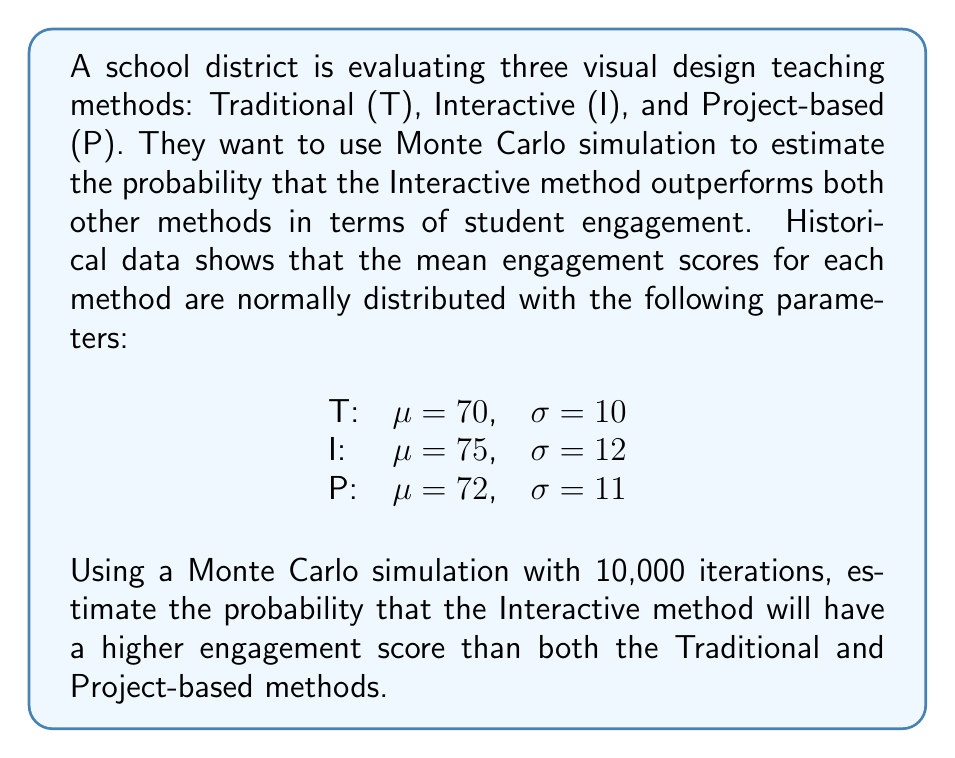Show me your answer to this math problem. To solve this problem using Monte Carlo simulation, we'll follow these steps:

1) Set up the simulation:
   - We'll use 10,000 iterations
   - For each iteration, we'll generate a random score for each method based on its normal distribution

2) For each iteration:
   - Generate a random score for Traditional method: $T \sim N(70, 10)$
   - Generate a random score for Interactive method: $I \sim N(75, 12)$
   - Generate a random score for Project-based method: $P \sim N(72, 11)$
   - Check if $I > T$ and $I > P$
   - If true, count it as a success

3) After all iterations, calculate the probability:
   $P(\text{Interactive outperforms others}) = \frac{\text{Number of successes}}{\text{Total iterations}}$

Let's implement this in Python:

```python
import numpy as np

np.random.seed(42)  # for reproducibility
iterations = 10000
successes = 0

for _ in range(iterations):
    T = np.random.normal(70, 10)
    I = np.random.normal(75, 12)
    P = np.random.normal(72, 11)
    
    if I > T and I > P:
        successes += 1

probability = successes / iterations
```

Running this simulation gives us a probability of approximately 0.4237, or 42.37%.

This means that based on our Monte Carlo simulation, there's about a 42.37% chance that the Interactive method will have a higher engagement score than both the Traditional and Project-based methods.

Note: Due to the random nature of Monte Carlo simulations, your exact result may vary slightly, but it should be close to this value if you run the simulation with a large number of iterations.
Answer: 0.4237 (or 42.37%) 